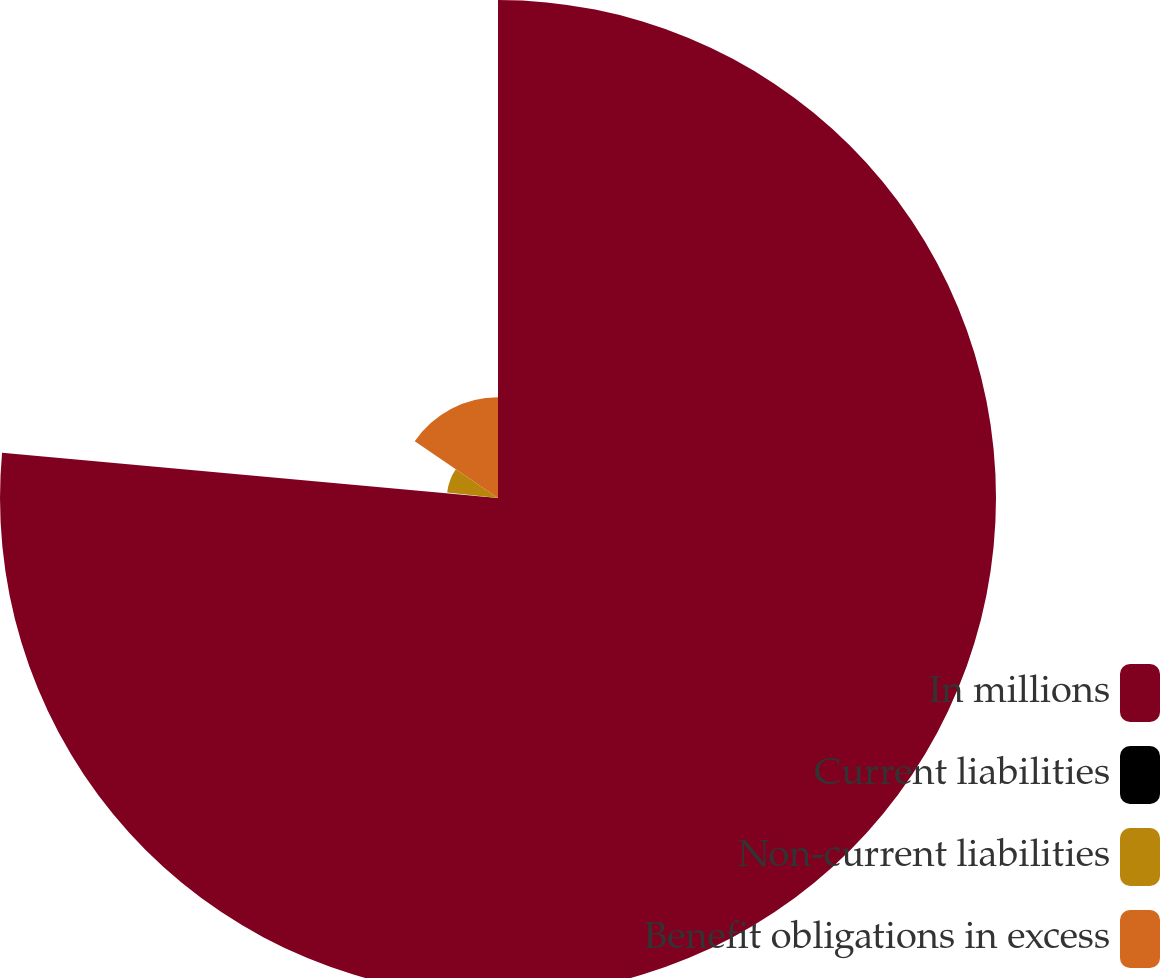<chart> <loc_0><loc_0><loc_500><loc_500><pie_chart><fcel>In millions<fcel>Current liabilities<fcel>Non-current liabilities<fcel>Benefit obligations in excess<nl><fcel>76.45%<fcel>0.23%<fcel>7.85%<fcel>15.47%<nl></chart> 